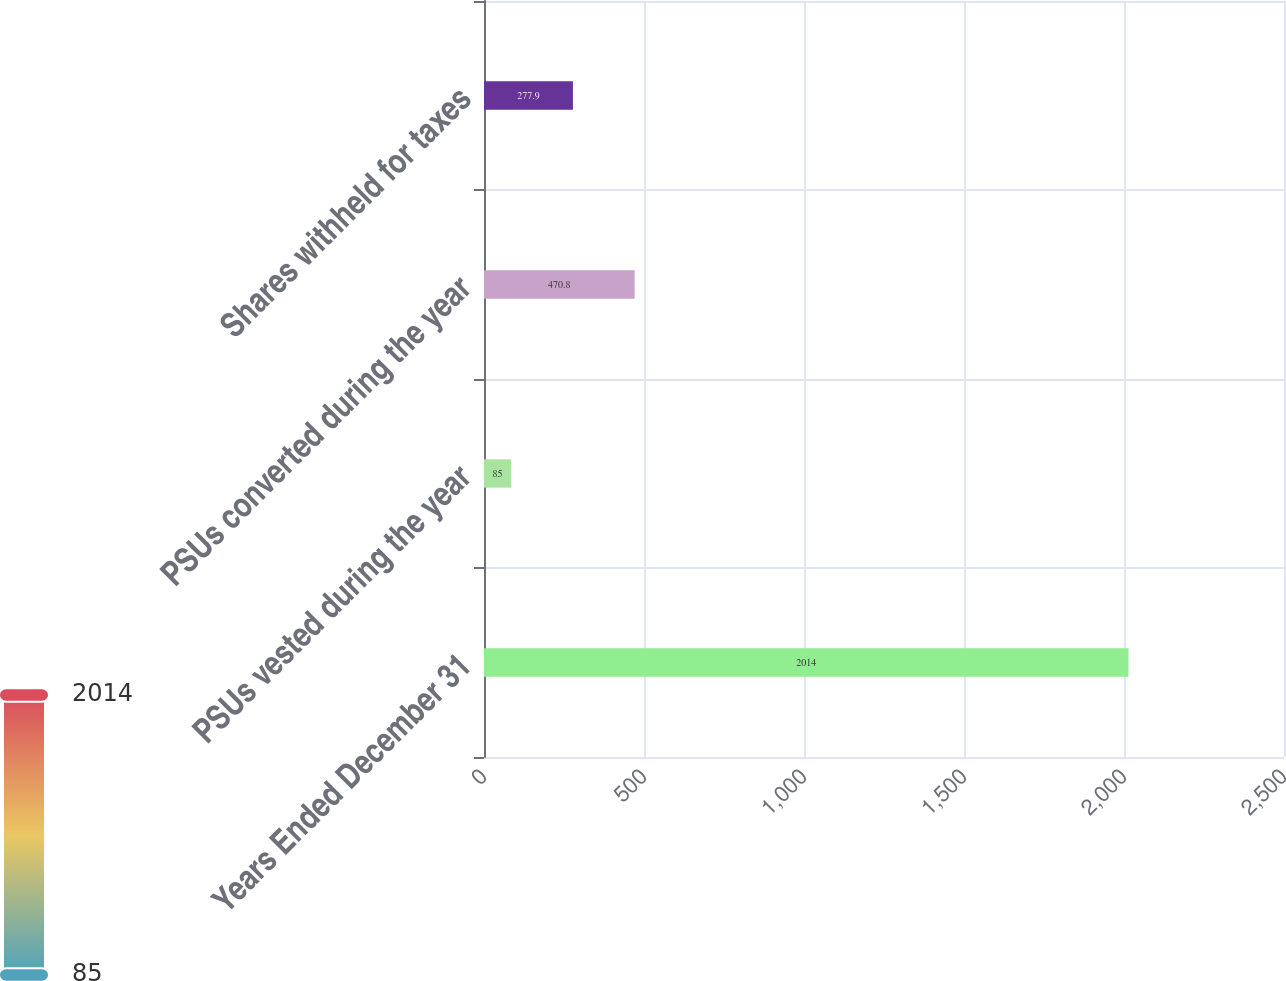Convert chart to OTSL. <chart><loc_0><loc_0><loc_500><loc_500><bar_chart><fcel>Years Ended December 31<fcel>PSUs vested during the year<fcel>PSUs converted during the year<fcel>Shares withheld for taxes<nl><fcel>2014<fcel>85<fcel>470.8<fcel>277.9<nl></chart> 